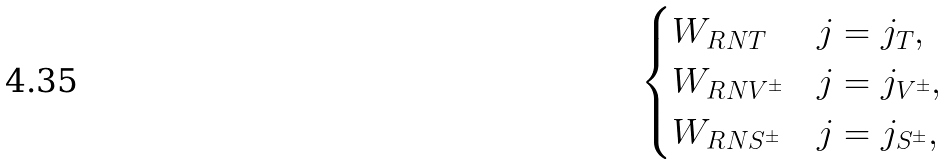<formula> <loc_0><loc_0><loc_500><loc_500>\begin{cases} W _ { R N T } & \text {$j=j_{T}$} , \\ W _ { R N V ^ { \pm } } & \text {$j=j_{V^{\pm}}$} , \\ W _ { R N S ^ { \pm } } & \text {$j=j_{S^{\pm}}$} , \end{cases}</formula> 